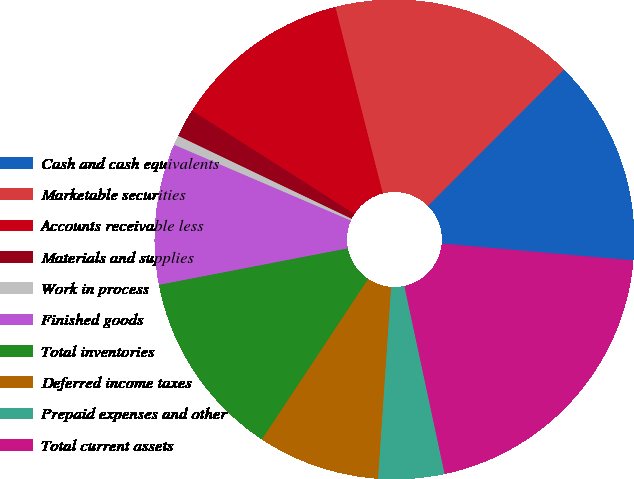Convert chart to OTSL. <chart><loc_0><loc_0><loc_500><loc_500><pie_chart><fcel>Cash and cash equivalents<fcel>Marketable securities<fcel>Accounts receivable less<fcel>Materials and supplies<fcel>Work in process<fcel>Finished goods<fcel>Total inventories<fcel>Deferred income taxes<fcel>Prepaid expenses and other<fcel>Total current assets<nl><fcel>13.92%<fcel>16.45%<fcel>12.02%<fcel>1.91%<fcel>0.65%<fcel>9.49%<fcel>12.65%<fcel>8.23%<fcel>4.44%<fcel>20.24%<nl></chart> 